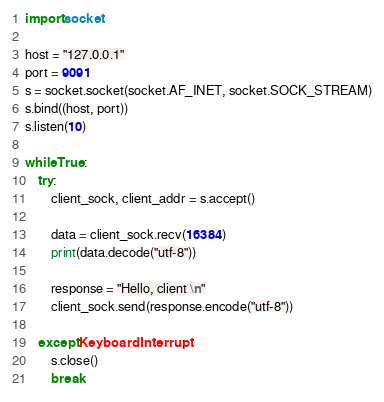Convert code to text. <code><loc_0><loc_0><loc_500><loc_500><_Python_>import socket

host = "127.0.0.1"
port = 9091
s = socket.socket(socket.AF_INET, socket.SOCK_STREAM)
s.bind((host, port))
s.listen(10)

while True:
	try:
		client_sock, client_addr = s.accept()
						
		data = client_sock.recv(16384)
		print(data.decode("utf-8"))
		
		response = "Hello, client \n"
		client_sock.send(response.encode("utf-8"))

	except KeyboardInterrupt:
		s.close()
		break

</code> 